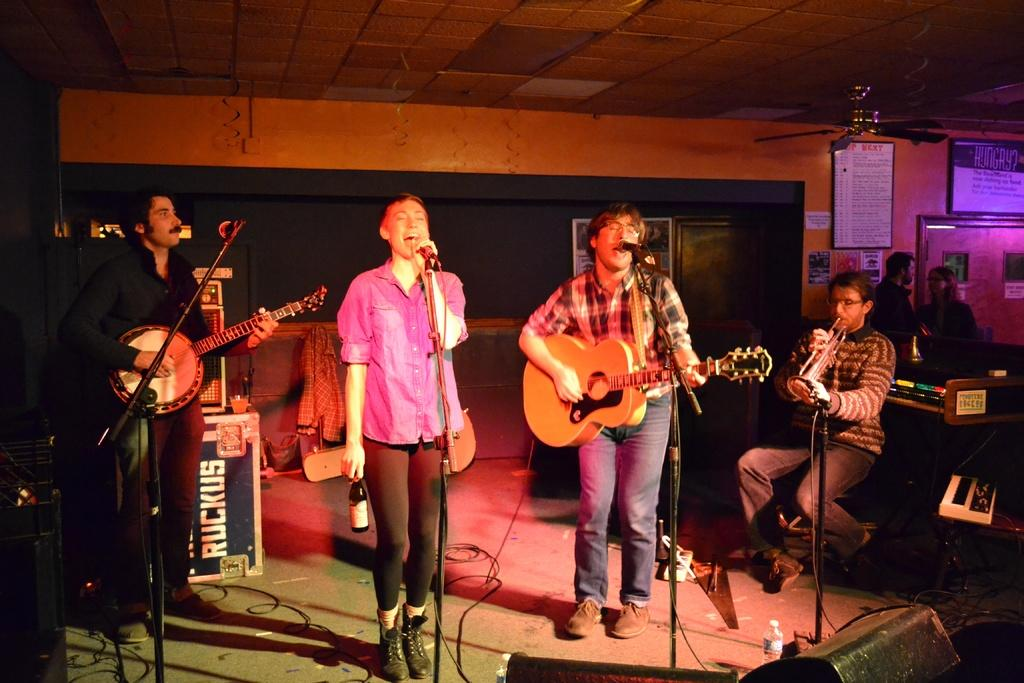What are the men in the image doing? The men in the image are standing and playing guitar. Are there any other activities happening in the image? Yes, there are two people talking to each other in one corner of the image. What can be seen on one side of a wall in the image? There is a display board on one side of a wall in the image. What type of banana is being used as a musical instrument in the image? There is no banana being used as a musical instrument in the image; the men are playing guitars. How many planes are visible in the image? There are no planes visible in the image. 